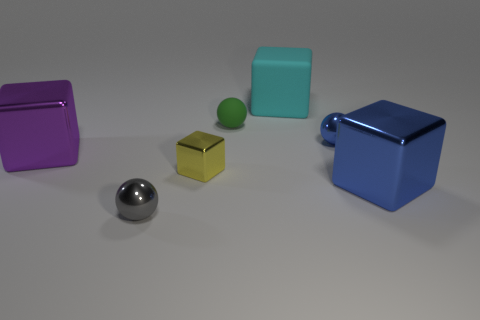Subtract all metallic spheres. How many spheres are left? 1 Subtract 2 cubes. How many cubes are left? 2 Subtract all blue cubes. How many cubes are left? 3 Add 2 metallic cubes. How many objects exist? 9 Subtract all balls. How many objects are left? 4 Subtract all brown spheres. Subtract all gray cubes. How many spheres are left? 3 Add 2 yellow cubes. How many yellow cubes exist? 3 Subtract 0 green cylinders. How many objects are left? 7 Subtract all large blue matte objects. Subtract all large blocks. How many objects are left? 4 Add 1 green objects. How many green objects are left? 2 